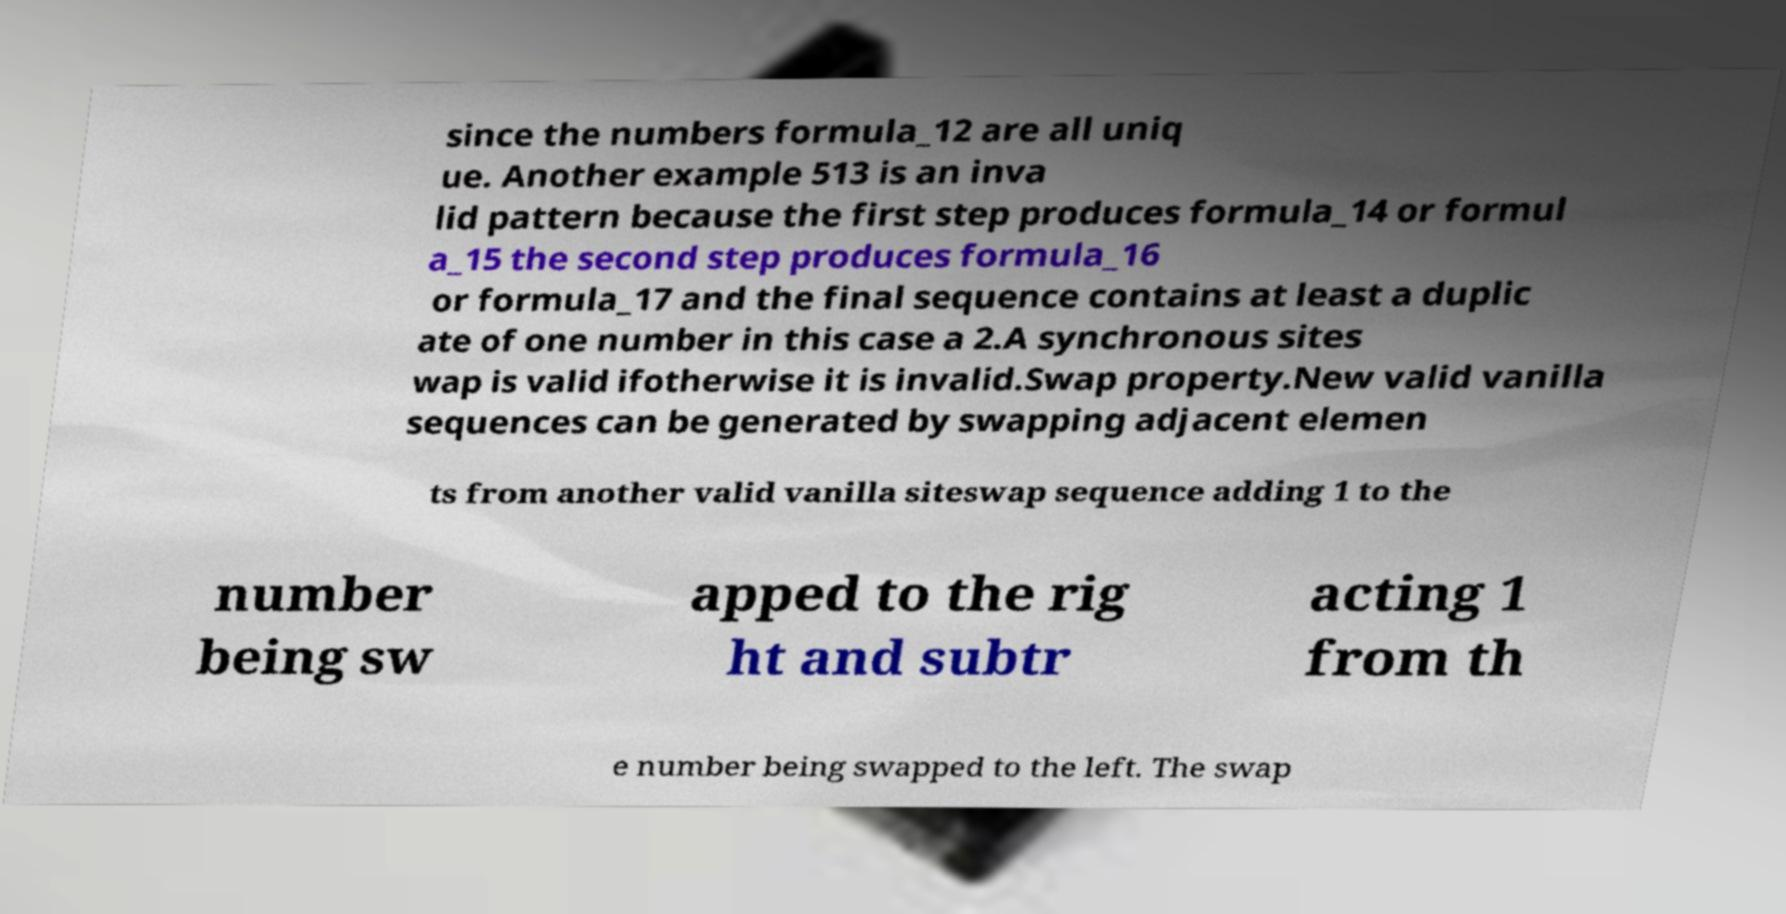Can you read and provide the text displayed in the image?This photo seems to have some interesting text. Can you extract and type it out for me? since the numbers formula_12 are all uniq ue. Another example 513 is an inva lid pattern because the first step produces formula_14 or formul a_15 the second step produces formula_16 or formula_17 and the final sequence contains at least a duplic ate of one number in this case a 2.A synchronous sites wap is valid ifotherwise it is invalid.Swap property.New valid vanilla sequences can be generated by swapping adjacent elemen ts from another valid vanilla siteswap sequence adding 1 to the number being sw apped to the rig ht and subtr acting 1 from th e number being swapped to the left. The swap 